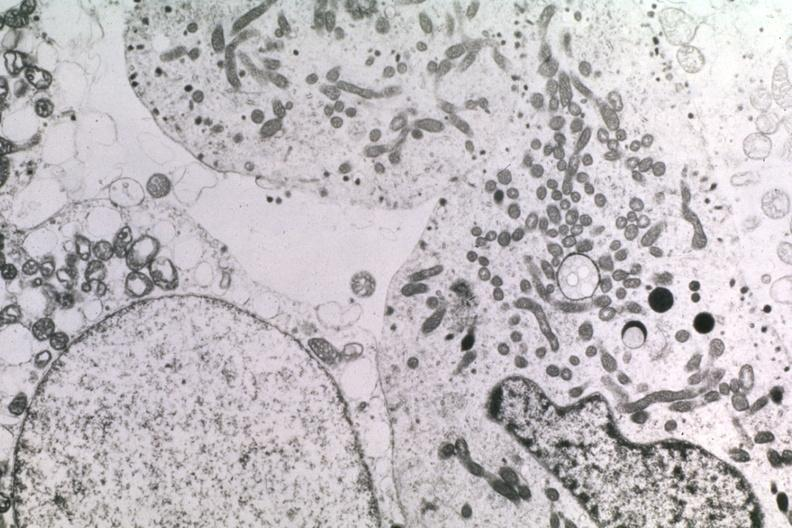s pituitary present?
Answer the question using a single word or phrase. Yes 